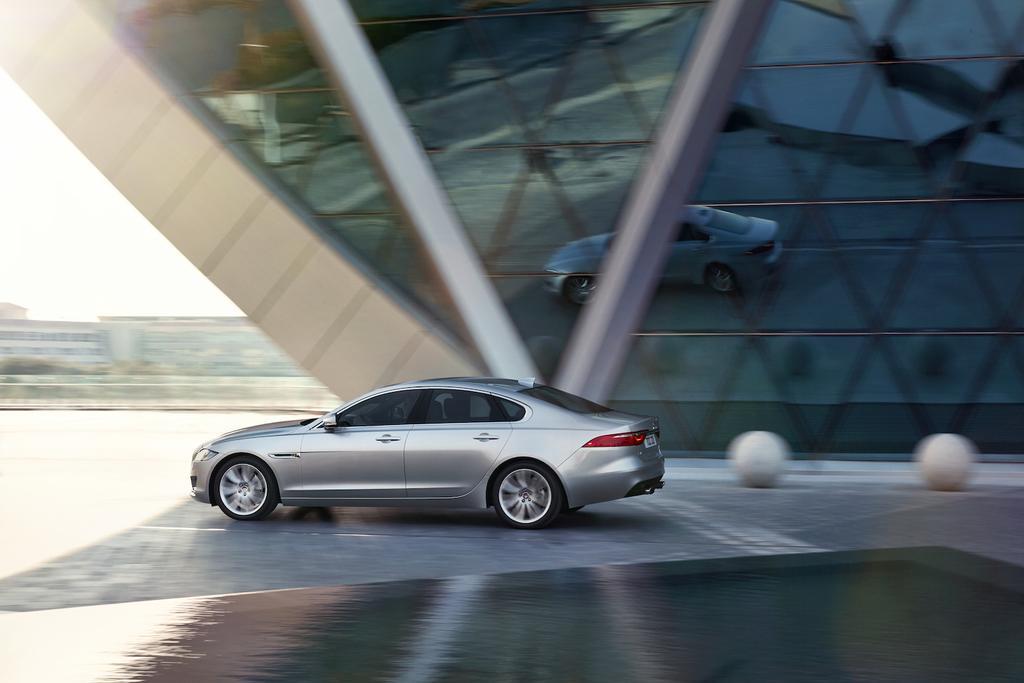In one or two sentences, can you explain what this image depicts? In this image I can see a silver colour car on the road. In the background I can see few buildings and on the right side of the image I can see two white colour things on the road. I can also see reflection of the car on the building and I can see this image is little bit blurry. 